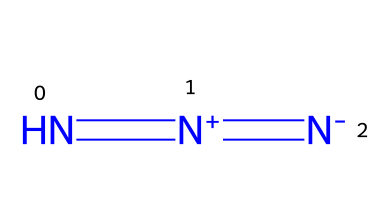What is the common name of the compound with this structure? The chemical represented by the SMILES N=[N+]=[N-] is known as hydrazoic acid. This is determined by recognizing the structure, which consists of three nitrogen atoms and a distinct configuration characteristic of azides.
Answer: hydrazoic acid How many nitrogen atoms are present in this compound? By analyzing the SMILES representation N=[N+]=[N-], we see there are three nitrogen atoms connected to each other. Counting each nitrogen in the structure confirms this.
Answer: three What type of bonds connects the nitrogen atoms in this molecule? Looking at the SMILES representation, N=[N+]=[N-] shows that there are double bonds between nitrogen atoms. Specifically, the notation with the equal signs indicates the presence of double bonds.
Answer: double bonds What is the charge of the nitrogen at the middle position? In the representation N=[N+]=[N-], the middle nitrogen has a positive charge indicated by the + sign. This demonstrates that it has lost an electron and carries a positive charge.
Answer: positive How many total bonds are present in this structure? Analyzing the structural formula from the SMILES, there are two double bonds between the nitrogen atoms. Each double bond consists of two bonds. Therefore, the total bonds are calculated as 2 bonds per double bond times 2 double bonds, resulting in four total bonds.
Answer: four What role does hydrazoic acid play in chemistry? Hydrazoic acid is a precursor to various azide compounds, which are used in organic synthesis and material science. The structure and chemical properties make it a valuable starting point for creating more complex azides.
Answer: precursor to azide compounds What is the oxidation state of the nitrogen atoms in hydrazoic acid? Each nitrogen in hydrazoic acid exhibits an unusual oxidation state, typically the nitrogen atoms in azides have an oxidation state around -1 depending on their connections, with the middle nitrogen being +1 due to its positive charge. Therefore, the average balances out for the structure as a whole.
Answer: -1, +1, -1 